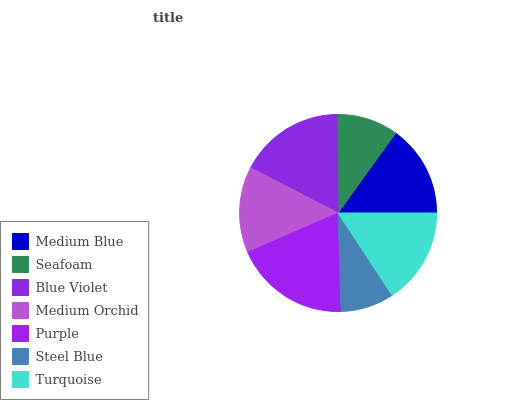Is Steel Blue the minimum?
Answer yes or no. Yes. Is Purple the maximum?
Answer yes or no. Yes. Is Seafoam the minimum?
Answer yes or no. No. Is Seafoam the maximum?
Answer yes or no. No. Is Medium Blue greater than Seafoam?
Answer yes or no. Yes. Is Seafoam less than Medium Blue?
Answer yes or no. Yes. Is Seafoam greater than Medium Blue?
Answer yes or no. No. Is Medium Blue less than Seafoam?
Answer yes or no. No. Is Medium Blue the high median?
Answer yes or no. Yes. Is Medium Blue the low median?
Answer yes or no. Yes. Is Steel Blue the high median?
Answer yes or no. No. Is Blue Violet the low median?
Answer yes or no. No. 